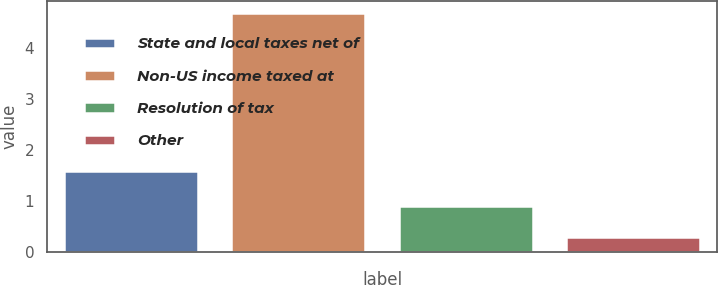Convert chart. <chart><loc_0><loc_0><loc_500><loc_500><bar_chart><fcel>State and local taxes net of<fcel>Non-US income taxed at<fcel>Resolution of tax<fcel>Other<nl><fcel>1.6<fcel>4.7<fcel>0.9<fcel>0.3<nl></chart> 